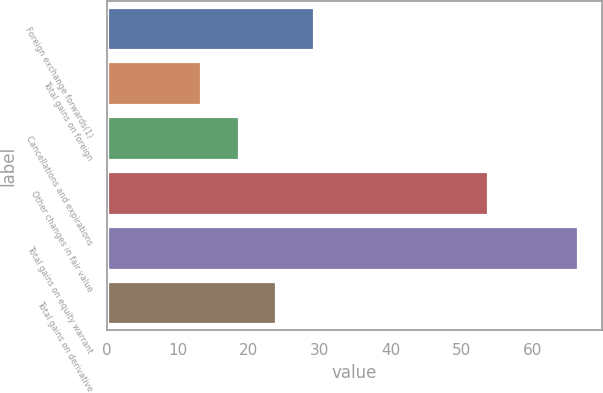Convert chart. <chart><loc_0><loc_0><loc_500><loc_500><bar_chart><fcel>Foreign exchange forwards(1)<fcel>Total gains on foreign<fcel>Cancellations and expirations<fcel>Other changes in fair value<fcel>Total gains on equity warrant<fcel>Total gains on derivative<nl><fcel>29.19<fcel>13.2<fcel>18.53<fcel>53.7<fcel>66.5<fcel>23.86<nl></chart> 